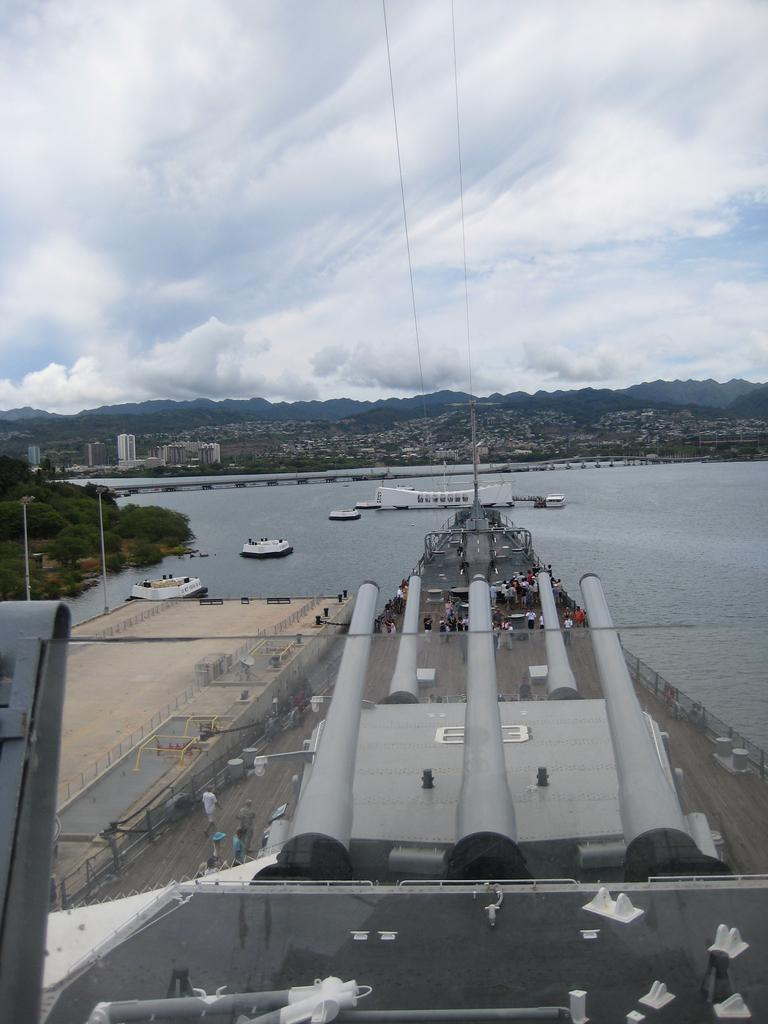What is the main subject of the image? There is a vehicle in the image. Can you describe the people in the image? There are people in the image. What type of structure is present in the image? There is a board bridge in the image. What can be seen on the water in the image? There are boats on the water in the image. What type of natural environment is visible in the background of the image? There are trees, buildings, hills, and the sky visible in the background of the image. Can you tell me how fast the snail is moving in the image? There is no snail present in the image, so it is not possible to determine its speed. 